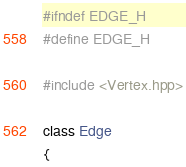Convert code to text. <code><loc_0><loc_0><loc_500><loc_500><_C++_>#ifndef EDGE_H
#define EDGE_H

#include <Vertex.hpp>

class Edge
{</code> 